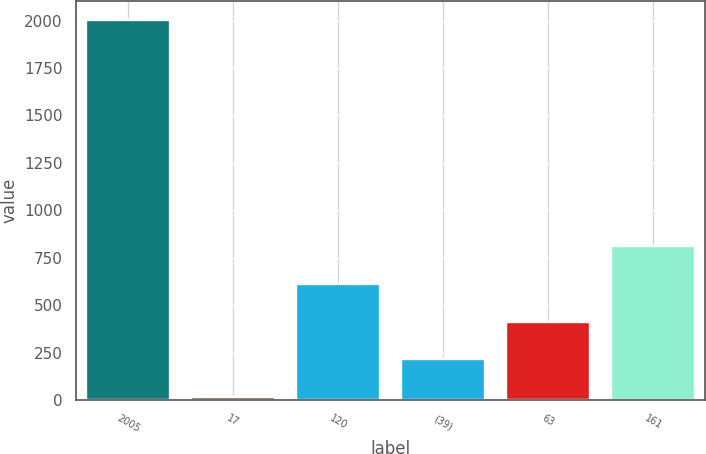<chart> <loc_0><loc_0><loc_500><loc_500><bar_chart><fcel>2005<fcel>17<fcel>120<fcel>(39)<fcel>63<fcel>161<nl><fcel>2004<fcel>17<fcel>613.1<fcel>215.7<fcel>414.4<fcel>811.8<nl></chart> 